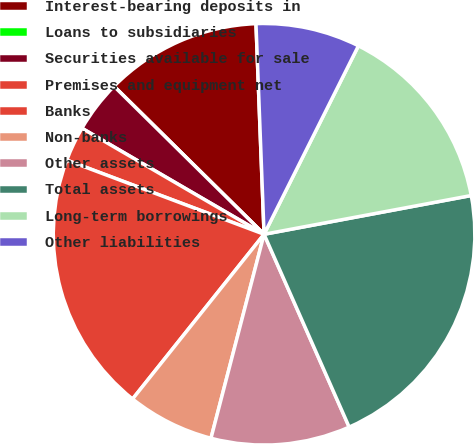Convert chart. <chart><loc_0><loc_0><loc_500><loc_500><pie_chart><fcel>Interest-bearing deposits in<fcel>Loans to subsidiaries<fcel>Securities available for sale<fcel>Premises and equipment net<fcel>Banks<fcel>Non-banks<fcel>Other assets<fcel>Total assets<fcel>Long-term borrowings<fcel>Other liabilities<nl><fcel>12.0%<fcel>0.0%<fcel>4.0%<fcel>2.67%<fcel>20.0%<fcel>6.67%<fcel>10.67%<fcel>21.33%<fcel>14.67%<fcel>8.0%<nl></chart> 